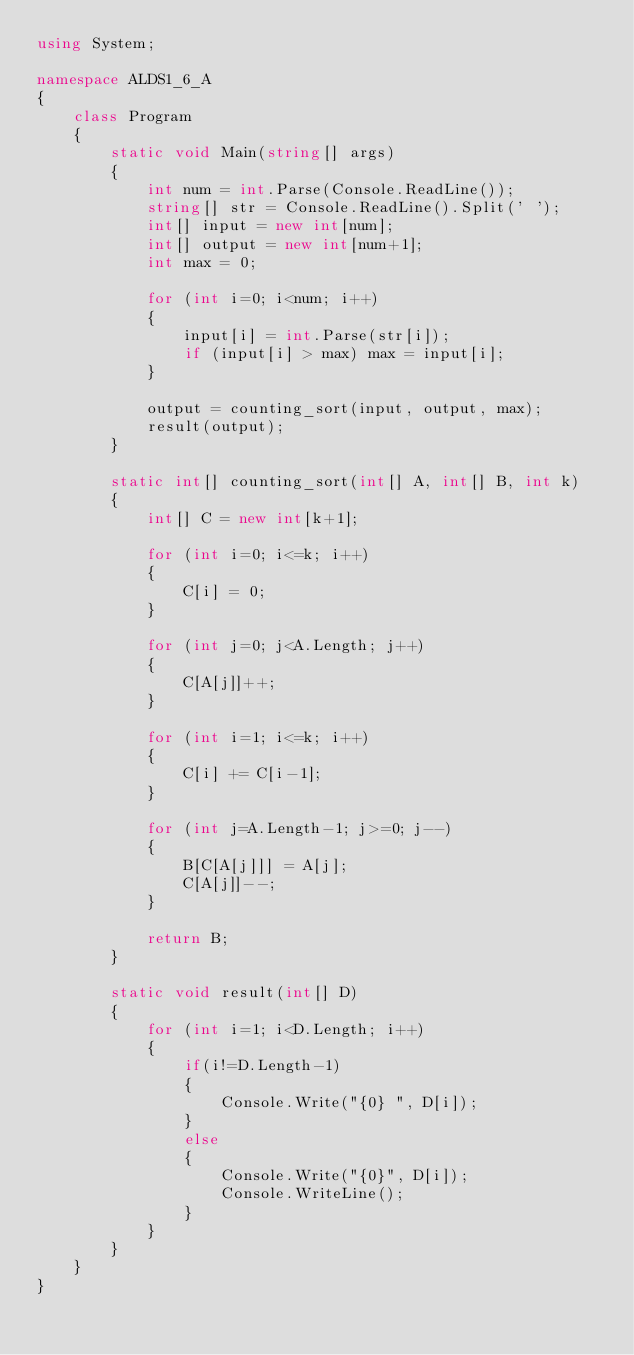Convert code to text. <code><loc_0><loc_0><loc_500><loc_500><_C#_>using System;

namespace ALDS1_6_A
{
    class Program
    {
        static void Main(string[] args)
        {
            int num = int.Parse(Console.ReadLine());
            string[] str = Console.ReadLine().Split(' ');
            int[] input = new int[num];
            int[] output = new int[num+1];
            int max = 0;

            for (int i=0; i<num; i++)
            {
                input[i] = int.Parse(str[i]);
                if (input[i] > max) max = input[i];
            }

            output = counting_sort(input, output, max);
            result(output);
        }

        static int[] counting_sort(int[] A, int[] B, int k)
        {
            int[] C = new int[k+1];

            for (int i=0; i<=k; i++)
            {
                C[i] = 0;
            }

            for (int j=0; j<A.Length; j++)
            {
                C[A[j]]++;
            }

            for (int i=1; i<=k; i++)
            {
                C[i] += C[i-1];
            }

            for (int j=A.Length-1; j>=0; j--)
            {
                B[C[A[j]]] = A[j];
                C[A[j]]--;
            }

            return B;
        }

        static void result(int[] D)
        {
            for (int i=1; i<D.Length; i++)
            {
                if(i!=D.Length-1)
                {
                    Console.Write("{0} ", D[i]);
                }
                else
                {
                    Console.Write("{0}", D[i]);
                    Console.WriteLine();
                }
            }
        }
    }
}</code> 